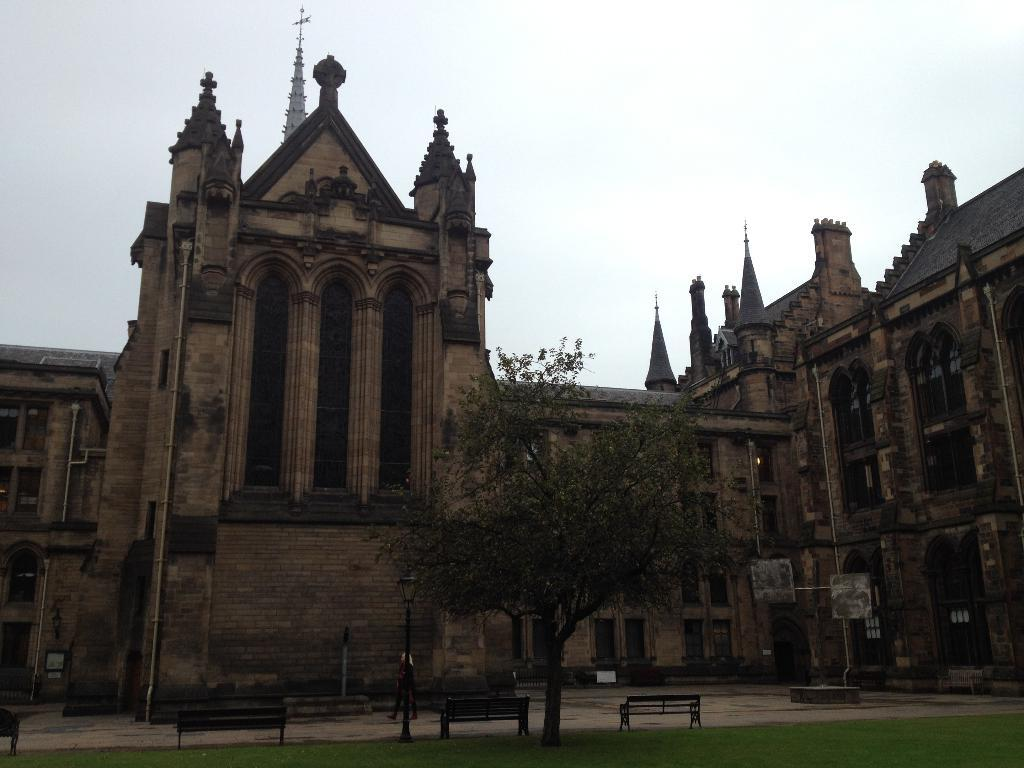What type of structure is present in the image? There is a building in the image. What feature can be seen on the building? The building has windows. What type of seating is available in the image? There are benches in the image. What type of vegetation is present in the image? There is grass in the image. What type of plant is present in the image? There is a tree in the image. What can be seen in the background of the image? The sky is visible in the background of the image. What type of bean is growing on the tree in the image? There are no beans present in the image, and the tree is not described as having any beans growing on it. 